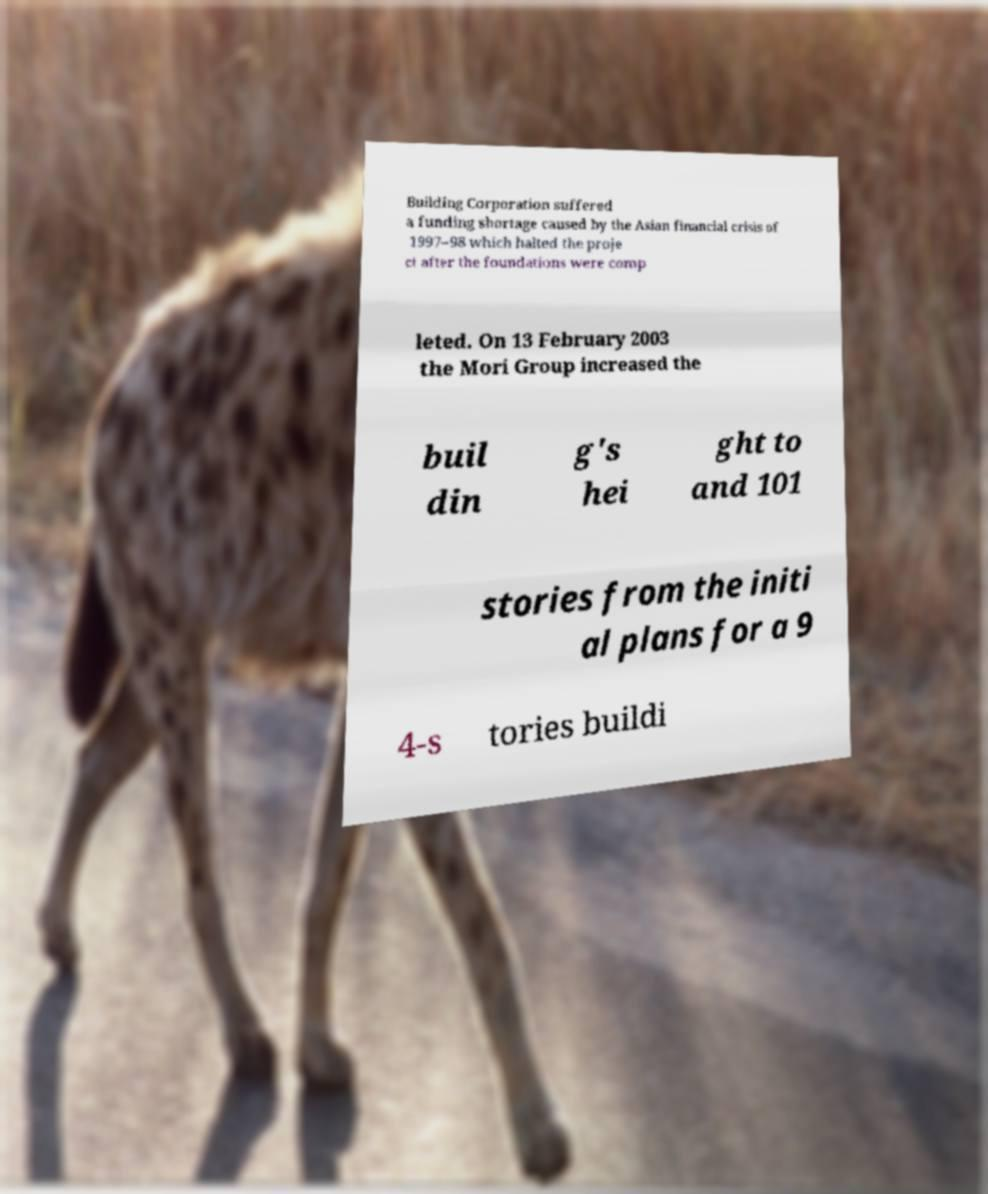Please identify and transcribe the text found in this image. Building Corporation suffered a funding shortage caused by the Asian financial crisis of 1997–98 which halted the proje ct after the foundations were comp leted. On 13 February 2003 the Mori Group increased the buil din g's hei ght to and 101 stories from the initi al plans for a 9 4-s tories buildi 